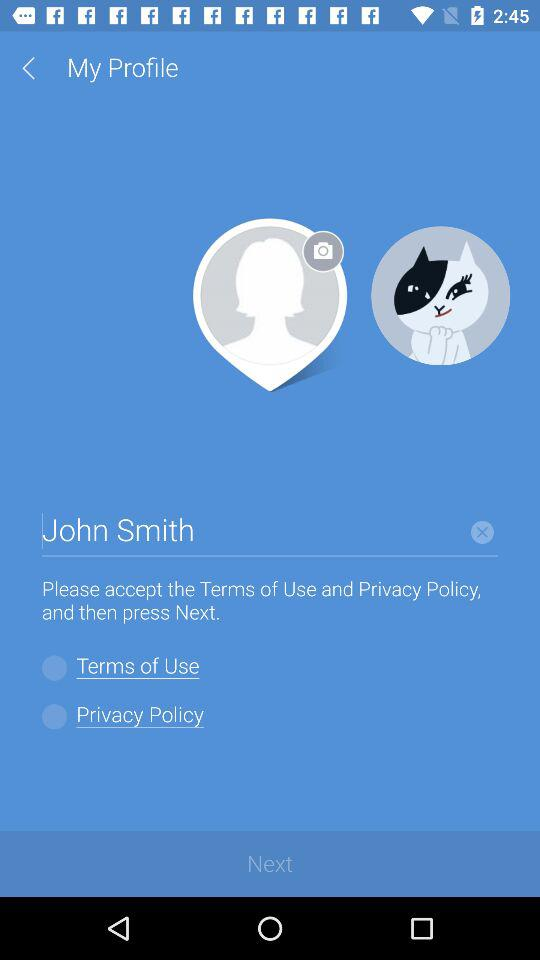What is the status of the terms of use? The status is off. 